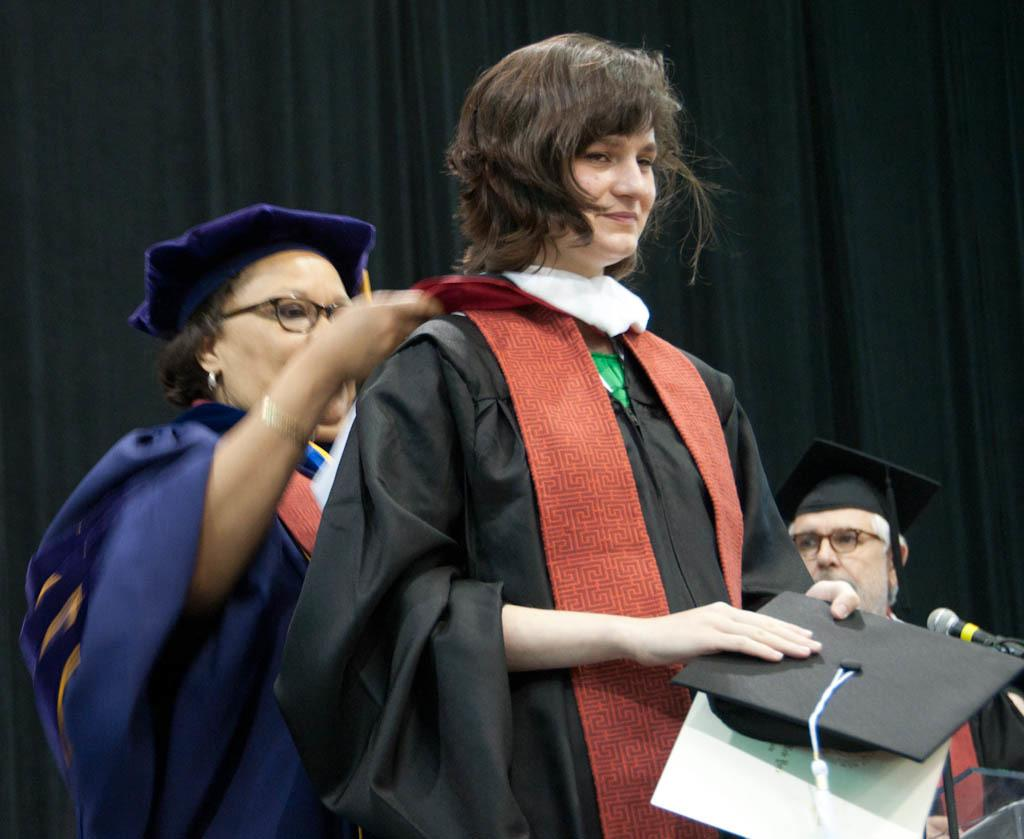Who is the main subject in the image? There is a lady in the image. What is the lady holding in her hands? The lady is holding a cap and a paper. Can you describe the people in the background of the image? There are two persons in the background of the image, and they are both wearing caps and spectacles. What object can be seen near the lady? There is a microphone in the image. What is present in the background of the image that might indicate a specific setting? There is a curtain in the background of the image. What type of dog is sitting next to the lady in the image? There is no dog present in the image. What role does the lady play in the movie, as seen in the image? The image does not provide any information about a movie or the lady's role in it. 